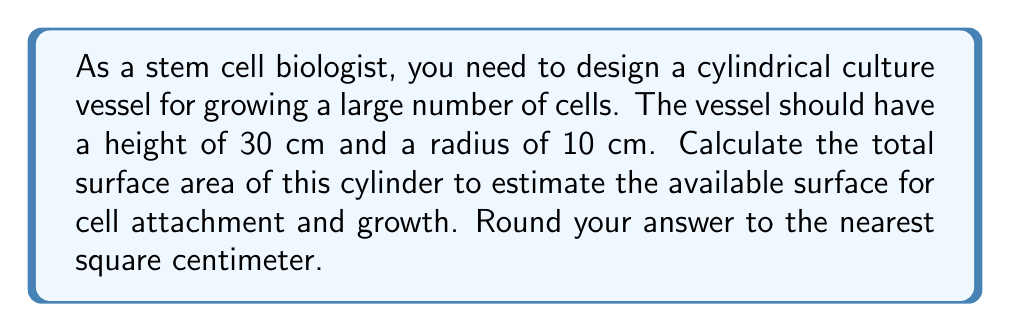Show me your answer to this math problem. To solve this problem, we need to calculate the surface area of a cylinder. The surface area of a cylinder consists of two circular bases and the lateral surface (curved side).

Let's break it down step-by-step:

1. Given dimensions:
   Height (h) = 30 cm
   Radius (r) = 10 cm

2. The formula for the surface area of a cylinder is:
   $$A = 2\pi r^2 + 2\pi rh$$
   Where:
   $A$ is the total surface area
   $r$ is the radius of the base
   $h$ is the height of the cylinder

3. Let's calculate each part:
   a) Area of the two circular bases: $2\pi r^2$
      $$2\pi (10\text{ cm})^2 = 2\pi (100\text{ cm}^2) = 200\pi\text{ cm}^2$$

   b) Area of the lateral surface: $2\pi rh$
      $$2\pi (10\text{ cm})(30\text{ cm}) = 600\pi\text{ cm}^2$$

4. Now, we add these two parts:
   $$A = 200\pi\text{ cm}^2 + 600\pi\text{ cm}^2 = 800\pi\text{ cm}^2$$

5. Calculate the final value:
   $$800\pi \approx 2513.27\text{ cm}^2$$

6. Rounding to the nearest square centimeter:
   $$2513\text{ cm}^2$$

This surface area represents the total area available for cell attachment and growth in your cylindrical culture vessel.
Answer: The total surface area of the cylindrical culture vessel is approximately 2513 cm². 